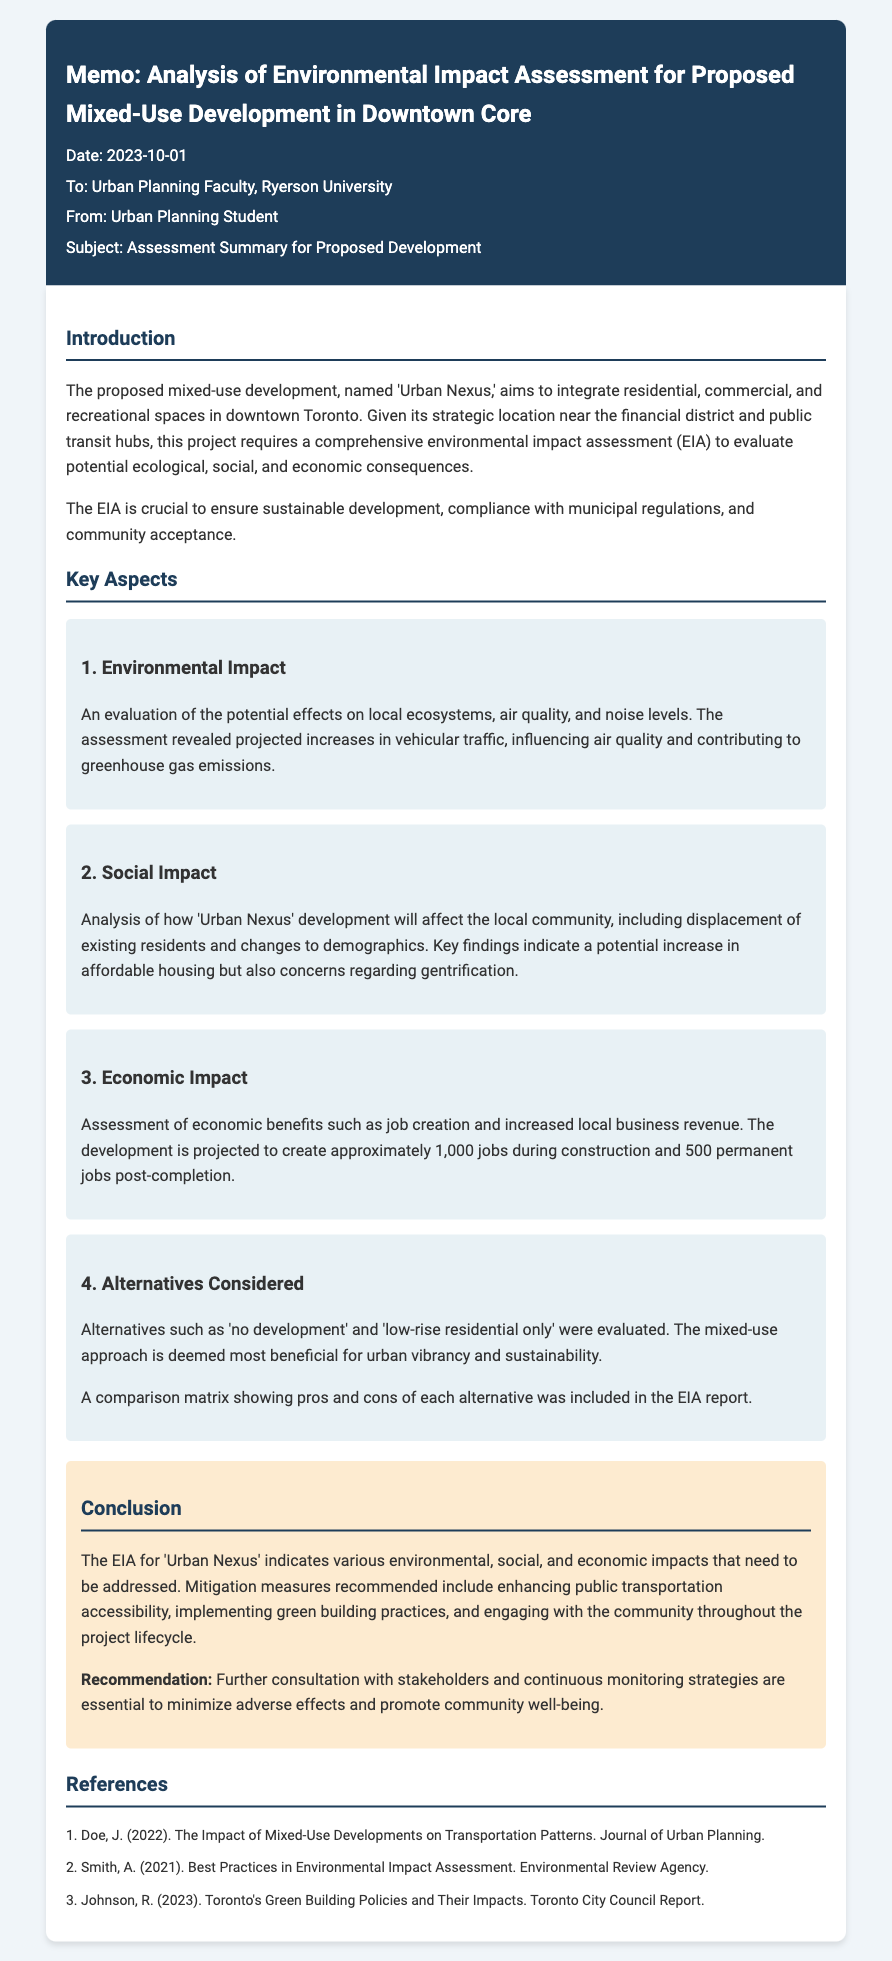what is the date of the memo? The date is mentioned prominently at the top of the document.
Answer: 2023-10-01 who is the proposed development named after? The document states the name of the proposed development.
Answer: Urban Nexus how many jobs is the development projected to create post-completion? The document provides specific job creation numbers for the project.
Answer: 500 what are the potential impacts on local air quality? The environmental impact section discusses effects related to air quality specifically.
Answer: Increases in vehicular traffic what is one alternative considered in the EIA? The document details alternatives evaluated during the assessment.
Answer: No development what is the major recommendation from the EIA? The conclusion provides recommendations based on the assessment findings.
Answer: Further consultation with stakeholders what is the main focus of the introduction section? The introduction outlines the purpose and needs of the environmental impact assessment.
Answer: Sustainable development how many jobs are expected during construction? The EIA report provides a specific number for job creation during the construction phase.
Answer: 1,000 